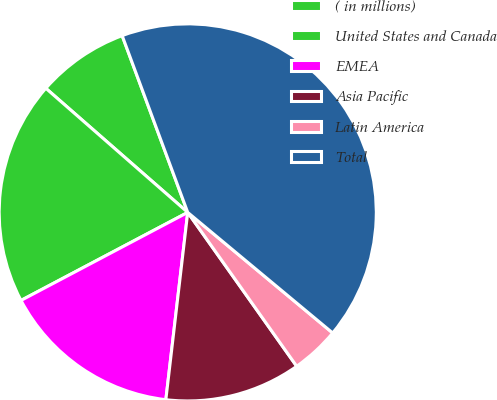Convert chart to OTSL. <chart><loc_0><loc_0><loc_500><loc_500><pie_chart><fcel>( in millions)<fcel>United States and Canada<fcel>EMEA<fcel>Asia Pacific<fcel>Latin America<fcel>Total<nl><fcel>7.91%<fcel>19.17%<fcel>15.42%<fcel>11.66%<fcel>4.15%<fcel>41.7%<nl></chart> 